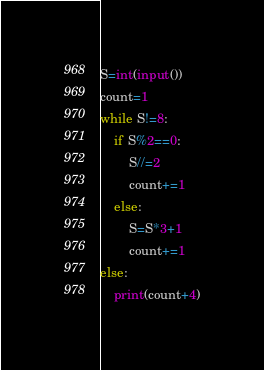<code> <loc_0><loc_0><loc_500><loc_500><_Python_>S=int(input())
count=1
while S!=8:
    if S%2==0:
        S//=2
        count+=1
    else:
        S=S*3+1
        count+=1
else:
    print(count+4)</code> 